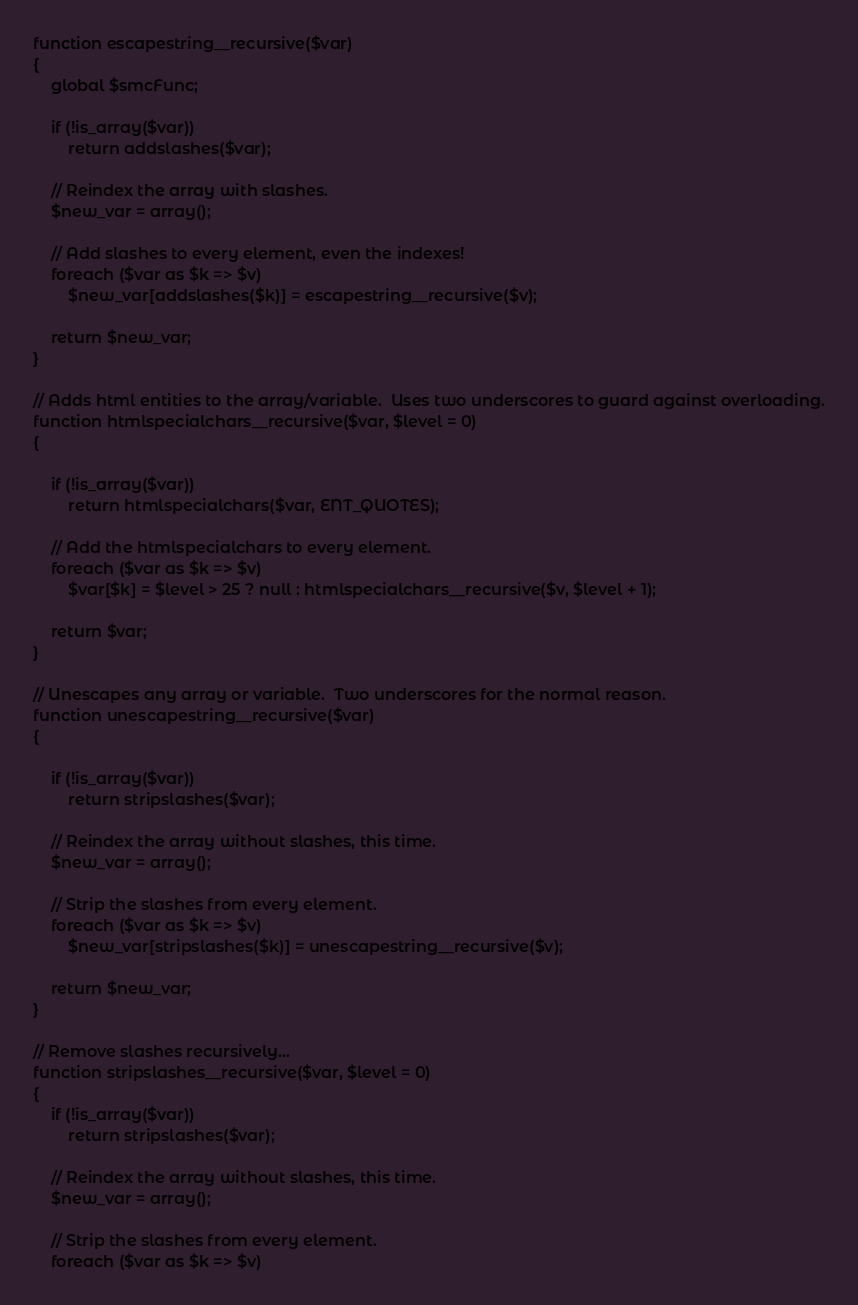Convert code to text. <code><loc_0><loc_0><loc_500><loc_500><_PHP_>function escapestring__recursive($var)
{
	global $smcFunc;

	if (!is_array($var))
		return addslashes($var);

	// Reindex the array with slashes.
	$new_var = array();

	// Add slashes to every element, even the indexes!
	foreach ($var as $k => $v)
		$new_var[addslashes($k)] = escapestring__recursive($v);

	return $new_var;
}

// Adds html entities to the array/variable.  Uses two underscores to guard against overloading.
function htmlspecialchars__recursive($var, $level = 0)
{

	if (!is_array($var))
		return htmlspecialchars($var, ENT_QUOTES);

	// Add the htmlspecialchars to every element.
	foreach ($var as $k => $v)
		$var[$k] = $level > 25 ? null : htmlspecialchars__recursive($v, $level + 1);

	return $var;
}

// Unescapes any array or variable.  Two underscores for the normal reason.
function unescapestring__recursive($var)
{

	if (!is_array($var))
		return stripslashes($var);

	// Reindex the array without slashes, this time.
	$new_var = array();

	// Strip the slashes from every element.
	foreach ($var as $k => $v)
		$new_var[stripslashes($k)] = unescapestring__recursive($v);

	return $new_var;
}

// Remove slashes recursively...
function stripslashes__recursive($var, $level = 0)
{
	if (!is_array($var))
		return stripslashes($var);

	// Reindex the array without slashes, this time.
	$new_var = array();

	// Strip the slashes from every element.
	foreach ($var as $k => $v)</code> 